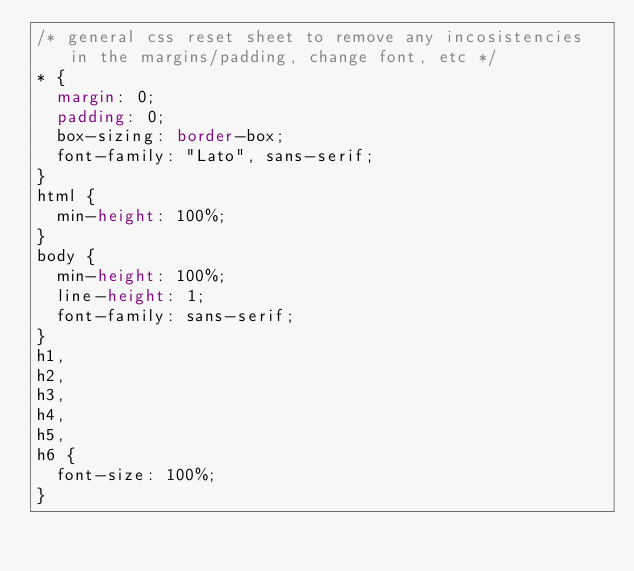Convert code to text. <code><loc_0><loc_0><loc_500><loc_500><_CSS_>/* general css reset sheet to remove any incosistencies in the margins/padding, change font, etc */
* {
  margin: 0;
  padding: 0;
  box-sizing: border-box;
  font-family: "Lato", sans-serif;
}
html {
  min-height: 100%;
}
body {
  min-height: 100%;
  line-height: 1;
  font-family: sans-serif;
}
h1,
h2,
h3,
h4,
h5,
h6 {
  font-size: 100%;
}
</code> 